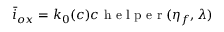Convert formula to latex. <formula><loc_0><loc_0><loc_500><loc_500>\bar { i } _ { o x } = k _ { 0 } ( c ) c h e l p e r ( \eta _ { f } , \lambda )</formula> 